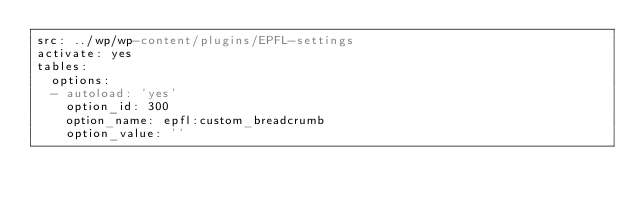Convert code to text. <code><loc_0><loc_0><loc_500><loc_500><_YAML_>src: ../wp/wp-content/plugins/EPFL-settings
activate: yes
tables:
  options:
  - autoload: 'yes'
    option_id: 300
    option_name: epfl:custom_breadcrumb
    option_value: ''</code> 